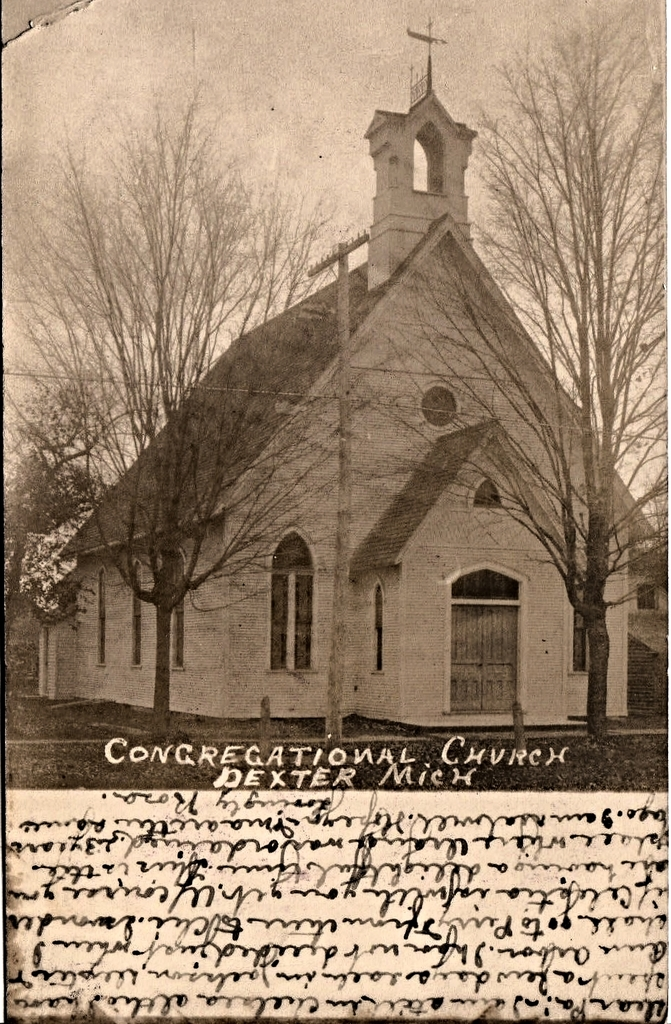Provide a one-sentence caption for the provided image.
Reference OCR token: CONGREGATIONAL, CHVRCH, DEXTER Vintage photo of the Congregational Church in Dixter Michigan. 